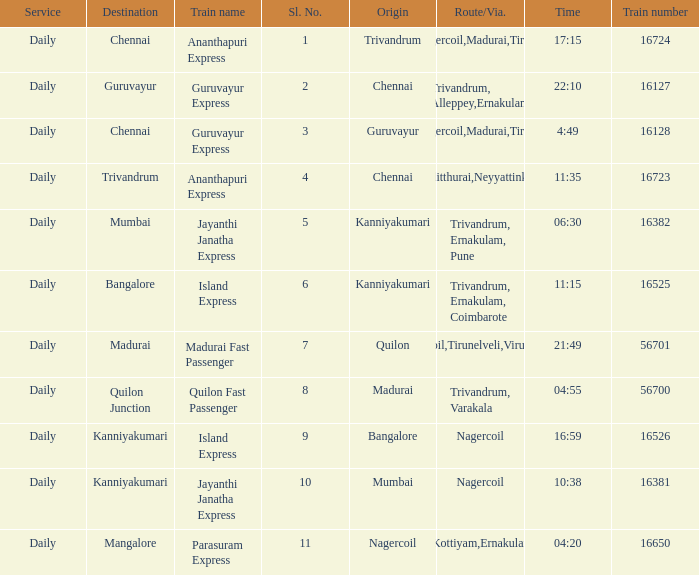What is the route/via when the destination is listed as Madurai? Nagercoil,Tirunelveli,Virudunagar. 